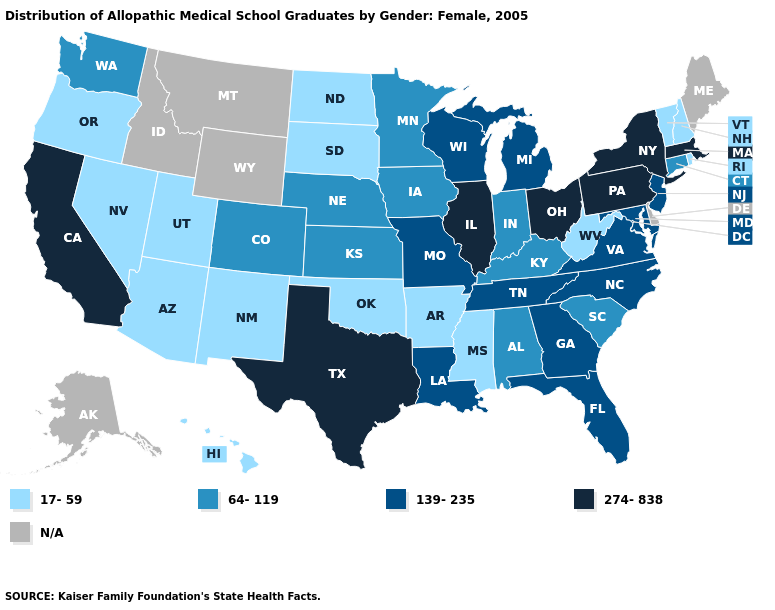What is the lowest value in the USA?
Be succinct. 17-59. Does the map have missing data?
Give a very brief answer. Yes. Name the states that have a value in the range 64-119?
Answer briefly. Alabama, Colorado, Connecticut, Indiana, Iowa, Kansas, Kentucky, Minnesota, Nebraska, South Carolina, Washington. What is the lowest value in the USA?
Be succinct. 17-59. What is the value of Oregon?
Concise answer only. 17-59. Among the states that border Michigan , which have the highest value?
Write a very short answer. Ohio. Name the states that have a value in the range N/A?
Write a very short answer. Alaska, Delaware, Idaho, Maine, Montana, Wyoming. Does Massachusetts have the lowest value in the USA?
Short answer required. No. What is the value of Missouri?
Keep it brief. 139-235. Does California have the highest value in the West?
Be succinct. Yes. What is the highest value in the USA?
Be succinct. 274-838. What is the lowest value in states that border West Virginia?
Short answer required. 64-119. What is the value of New Hampshire?
Keep it brief. 17-59. Does the first symbol in the legend represent the smallest category?
Keep it brief. Yes. Does Alabama have the highest value in the USA?
Concise answer only. No. 